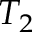Convert formula to latex. <formula><loc_0><loc_0><loc_500><loc_500>T _ { 2 }</formula> 